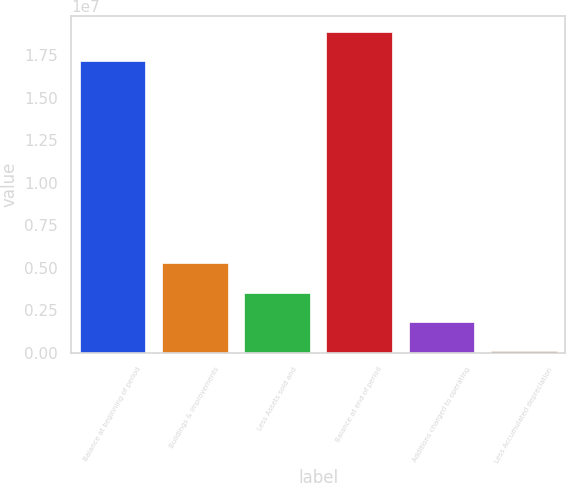Convert chart to OTSL. <chart><loc_0><loc_0><loc_500><loc_500><bar_chart><fcel>Balance at beginning of period<fcel>Buildings & improvements<fcel>Less Assets sold and<fcel>Balance at end of period<fcel>Additions charged to operating<fcel>Less Accumulated depreciation<nl><fcel>1.71407e+07<fcel>5.26276e+06<fcel>3.54402e+06<fcel>1.88595e+07<fcel>1.82528e+06<fcel>106534<nl></chart> 